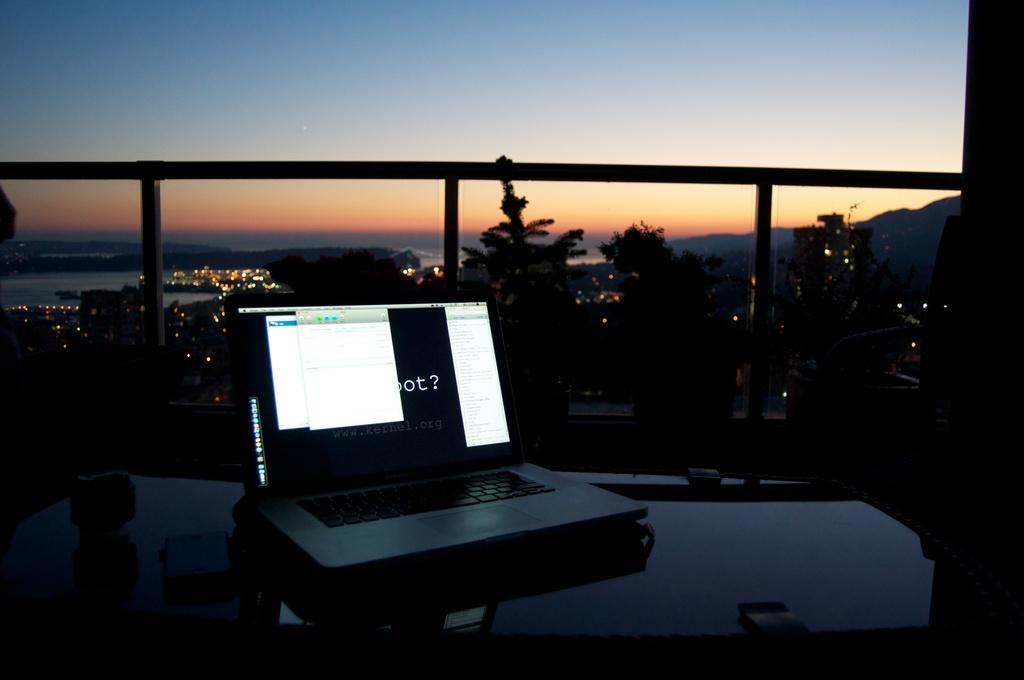Provide a one-sentence caption for the provided image. A laptop displays an image with www.kernel.org written on it. 